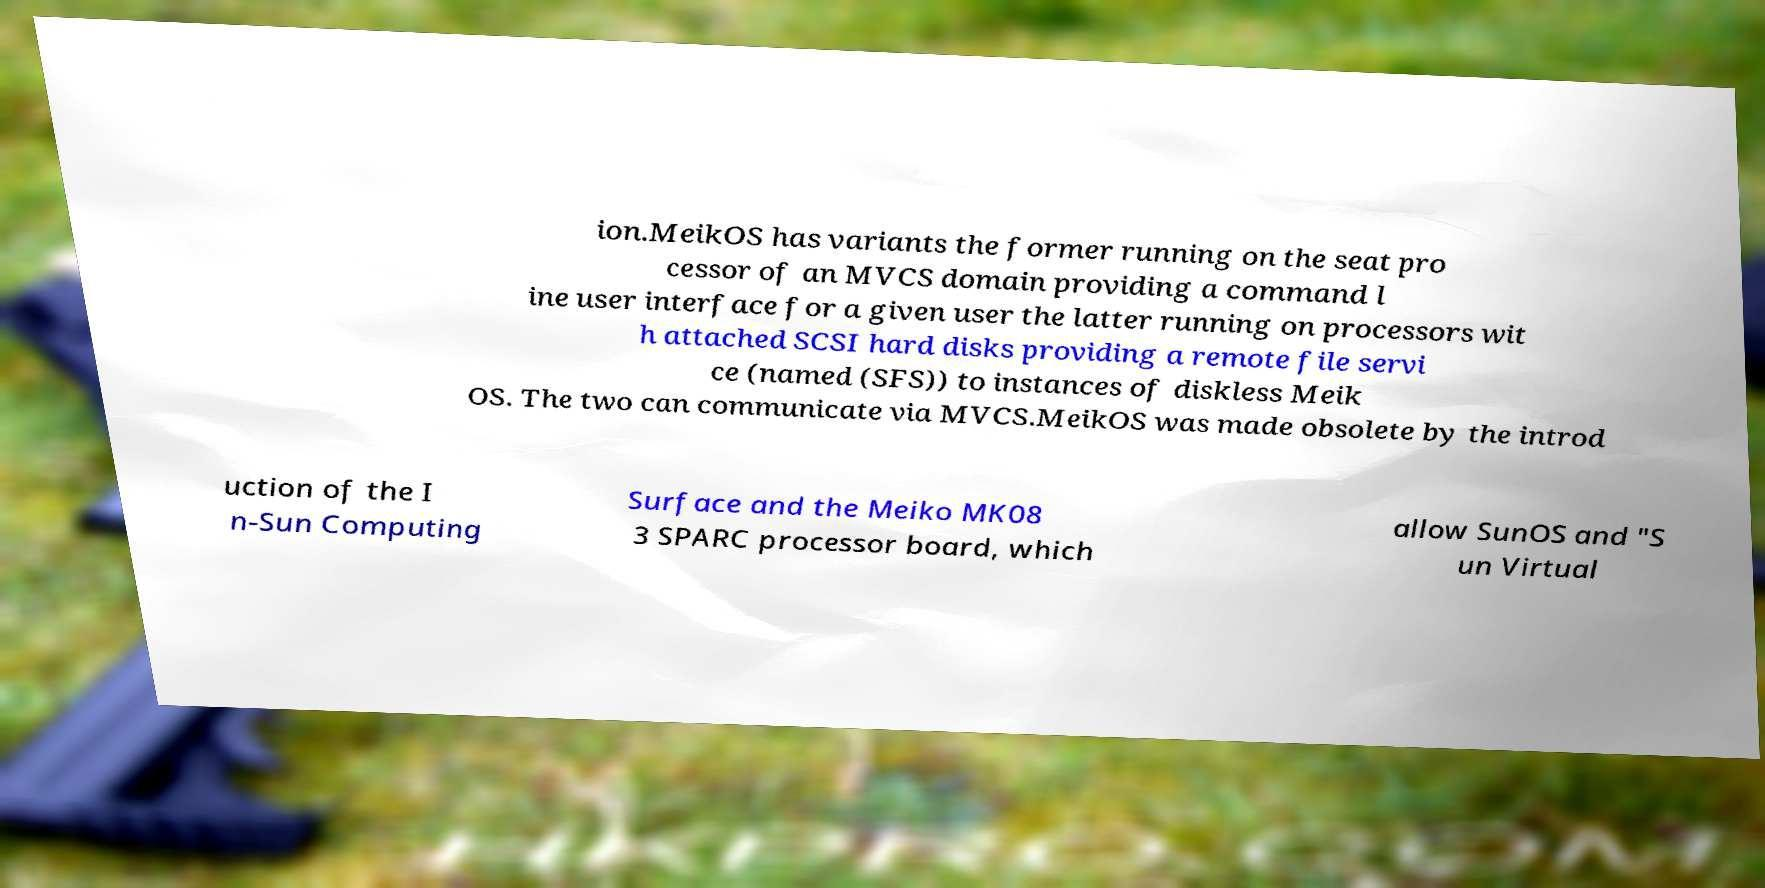I need the written content from this picture converted into text. Can you do that? ion.MeikOS has variants the former running on the seat pro cessor of an MVCS domain providing a command l ine user interface for a given user the latter running on processors wit h attached SCSI hard disks providing a remote file servi ce (named (SFS)) to instances of diskless Meik OS. The two can communicate via MVCS.MeikOS was made obsolete by the introd uction of the I n-Sun Computing Surface and the Meiko MK08 3 SPARC processor board, which allow SunOS and "S un Virtual 